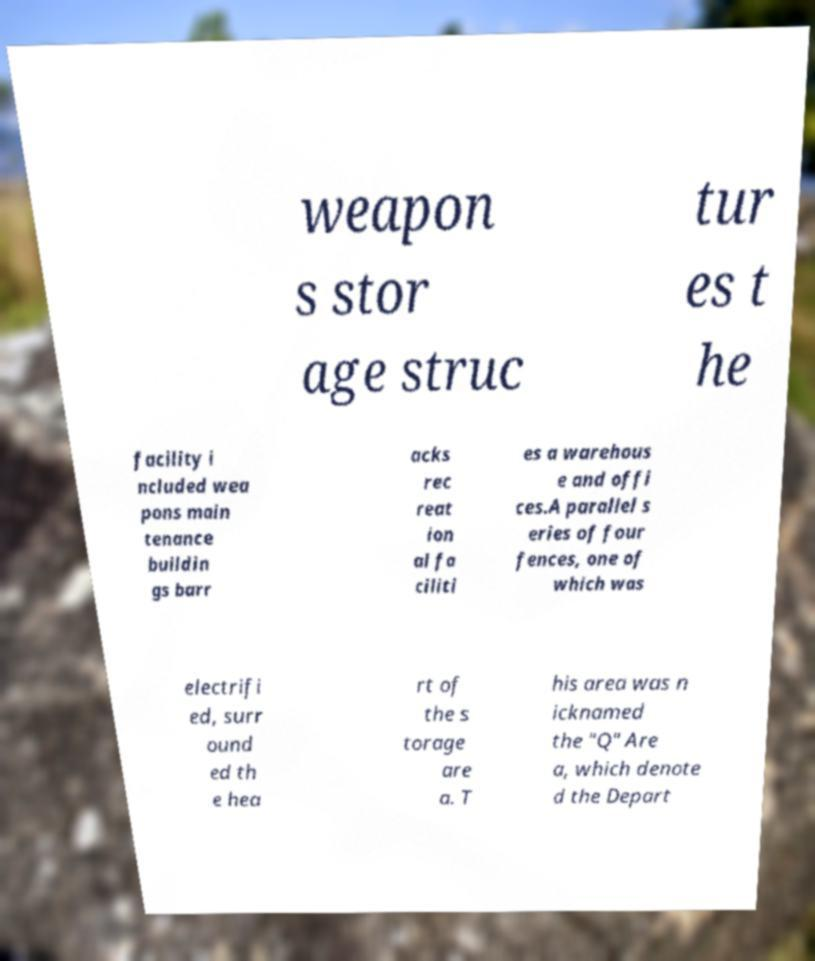Could you extract and type out the text from this image? weapon s stor age struc tur es t he facility i ncluded wea pons main tenance buildin gs barr acks rec reat ion al fa ciliti es a warehous e and offi ces.A parallel s eries of four fences, one of which was electrifi ed, surr ound ed th e hea rt of the s torage are a. T his area was n icknamed the "Q" Are a, which denote d the Depart 